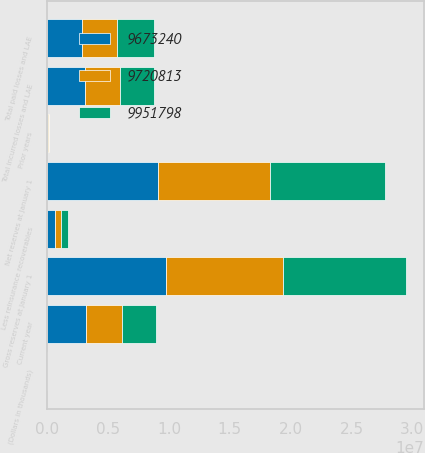<chart> <loc_0><loc_0><loc_500><loc_500><stacked_bar_chart><ecel><fcel>(Dollars in thousands)<fcel>Gross reserves at January 1<fcel>Less reinsurance recoverables<fcel>Net reserves at January 1<fcel>Current year<fcel>Prior years<fcel>Total incurred losses and LAE<fcel>Total paid losses and LAE<nl><fcel>9.67324e+06<fcel>2015<fcel>9.72081e+06<fcel>627082<fcel>9.09373e+06<fcel>3.17048e+06<fcel>68567<fcel>3.10192e+06<fcel>2.88405e+06<nl><fcel>9.72081e+06<fcel>2014<fcel>9.67324e+06<fcel>473866<fcel>9.19937e+06<fcel>2.9464e+06<fcel>39862<fcel>2.90653e+06<fcel>2.85152e+06<nl><fcel>9.9518e+06<fcel>2013<fcel>1.00691e+07<fcel>602750<fcel>9.4663e+06<fcel>2.81849e+06<fcel>18239<fcel>2.80025e+06<fcel>3.01854e+06<nl></chart> 